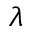<formula> <loc_0><loc_0><loc_500><loc_500>\lambda</formula> 